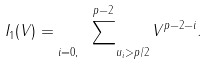Convert formula to latex. <formula><loc_0><loc_0><loc_500><loc_500>I _ { 1 } ( V ) = \sum _ { i = 0 , \quad u _ { i } > p / 2 } ^ { p - 2 } V ^ { p - 2 - i } .</formula> 